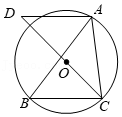Suppose the circle O has a radius of 'r'. If we know that BC is the diameter, can we derive the circle's circumference and area from this? Yes, if BC is a diameter of the circle and its length equals 2r (where 'r' is the radius), then the circumference of the circle can be calculated using the formula C=2πr which simplifies to C=π(BC). For the area, the formula A=πr² translates to A=π(0.5BC)² simplifying further to A=0.25π(BC)², providing direct methods to compute both the circumference and the area based on BC. 